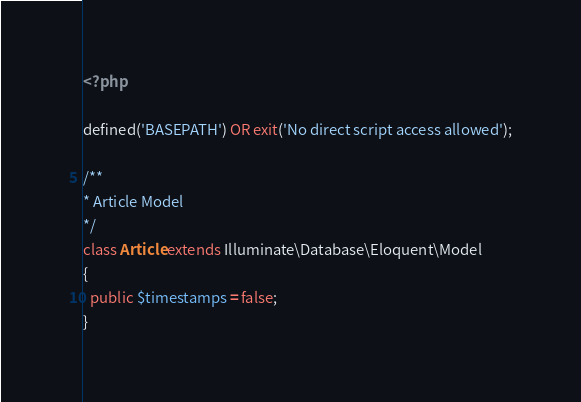<code> <loc_0><loc_0><loc_500><loc_500><_PHP_><?php

defined('BASEPATH') OR exit('No direct script access allowed');

/**
* Article Model
*/
class Article extends Illuminate\Database\Eloquent\Model
{
  public $timestamps = false;
}</code> 